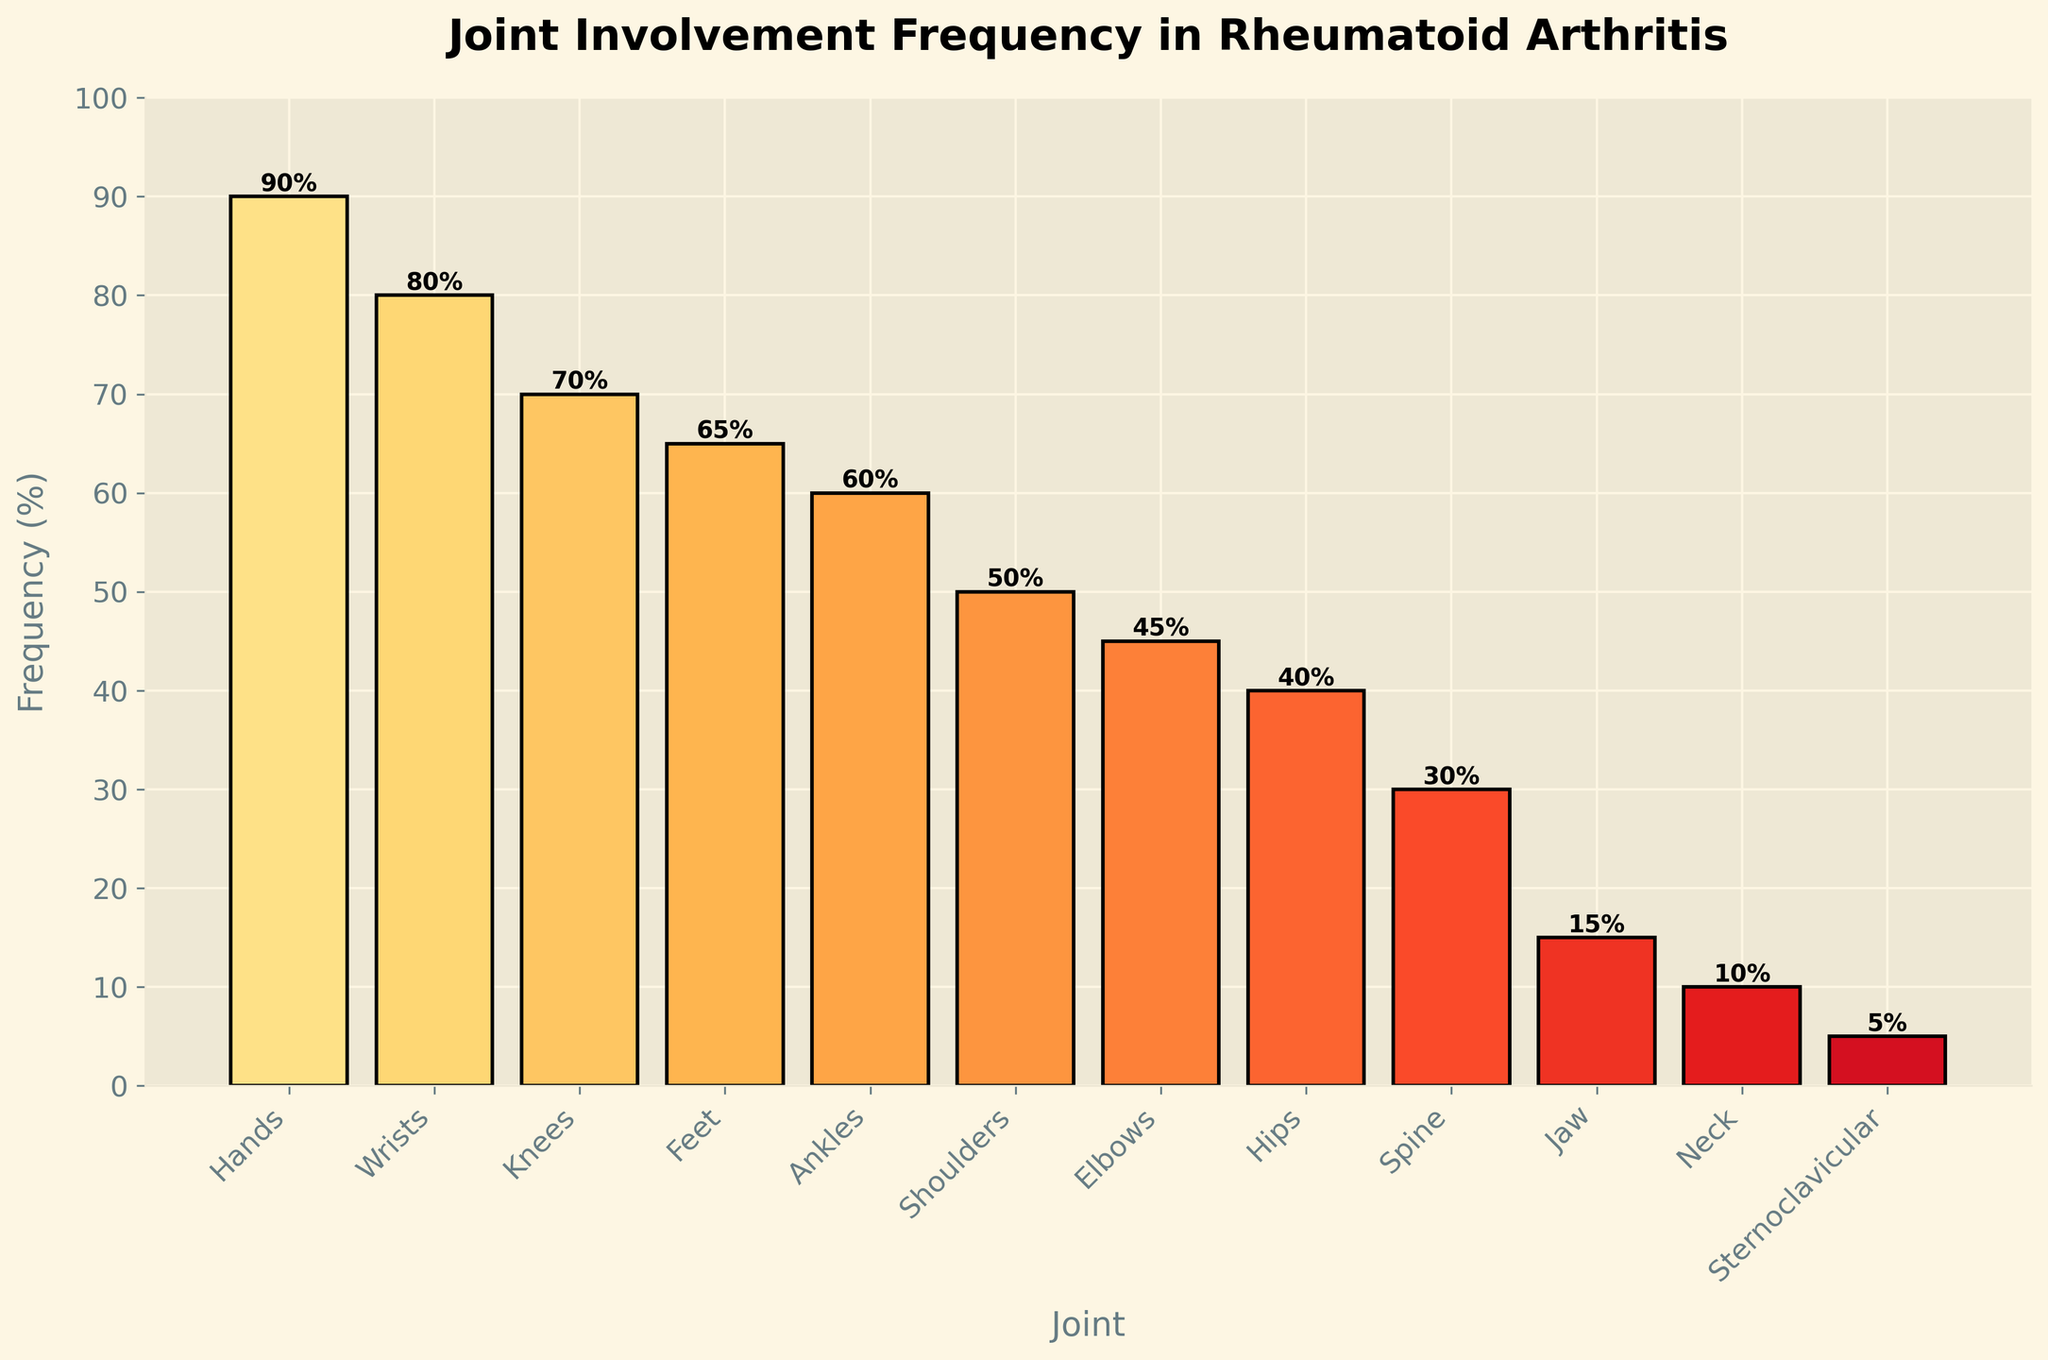What is the most frequently involved joint in rheumatoid arthritis according to the figure? The bar chart shows different joints and their respective frequencies of involvement. The highest bar represents the hands, which have a frequency of 90%.
Answer: Hands How many joints have a frequency of involvement higher than 50%? By examining the heights of the bars and their corresponding frequencies, the joints with frequencies higher than 50% are Hands (90), Wrists (80), Knees (70), Feet (65), and Ankles (60). There are five such joints.
Answer: 5 Which joint is less frequently involved: Shoulders or Elbows? By comparing the heights of the bars for Shoulders and Elbows, the bar for Elbows is shorter, indicating a lower frequency. Elbows have a frequency of 45%, while Shoulders have 50%.
Answer: Elbows What is the combined frequency of involvement for Knees and Feet? The Knees have a frequency of 70% and the Feet have 65%. Adding these two frequencies together: 70% + 65% = 135%.
Answer: 135% By how much is the involvement frequency of Hands greater than that of Ankles? Hands have a frequency of 90% and Ankles have 60%. The difference is 90% - 60% = 30%.
Answer: 30% What is the median value of the joint involvement frequencies presented? To find the median, list out all frequencies in ascending order: 5, 10, 15, 30, 40, 45, 50, 60, 65, 70, 80, 90. The middle two numbers in the even set are 50 and 60. The median is the average of these two values: (50 + 60) / 2 = 55%.
Answer: 55% Which joint has the least frequency of involvement according to the figure? The smallest bar in the bar chart represents the Sternoclavicular joint, which has a frequency of 5%.
Answer: Sternoclavicular What is the percentage difference between the involvement frequency of Wrists and Hips? Wrists have a frequency of 80% and Hips have 40%. The difference is 80% - 40% = 40%.
Answer: 40% Among the joints listed, how many joints have a frequency of involvement less than or equal to 30%? By examining the bars, the joints with frequencies less than or equal to 30% are Spine (30), Jaw (15), Neck (10), and Sternoclavicular (5). There are four such joints.
Answer: 4 